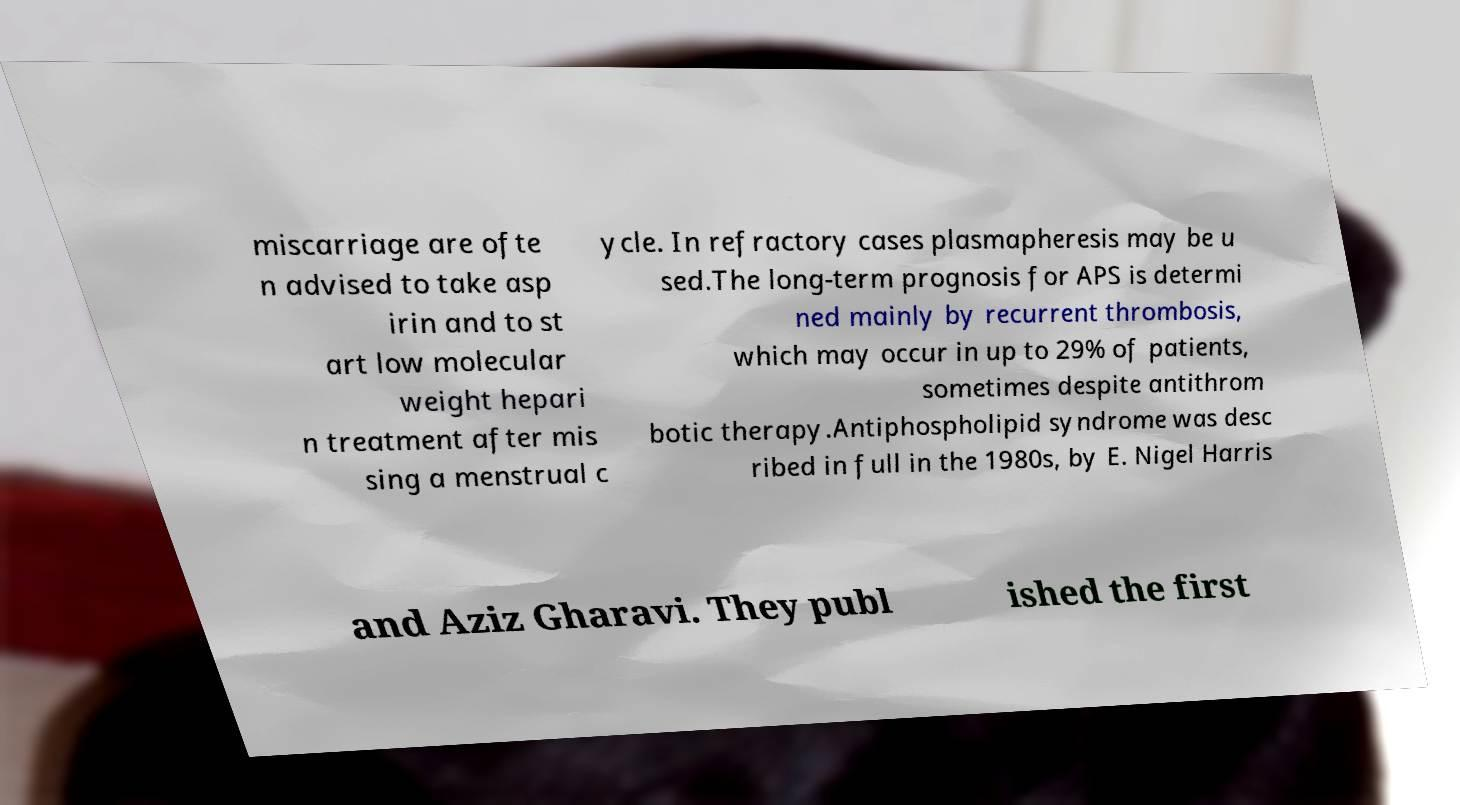What messages or text are displayed in this image? I need them in a readable, typed format. miscarriage are ofte n advised to take asp irin and to st art low molecular weight hepari n treatment after mis sing a menstrual c ycle. In refractory cases plasmapheresis may be u sed.The long-term prognosis for APS is determi ned mainly by recurrent thrombosis, which may occur in up to 29% of patients, sometimes despite antithrom botic therapy.Antiphospholipid syndrome was desc ribed in full in the 1980s, by E. Nigel Harris and Aziz Gharavi. They publ ished the first 